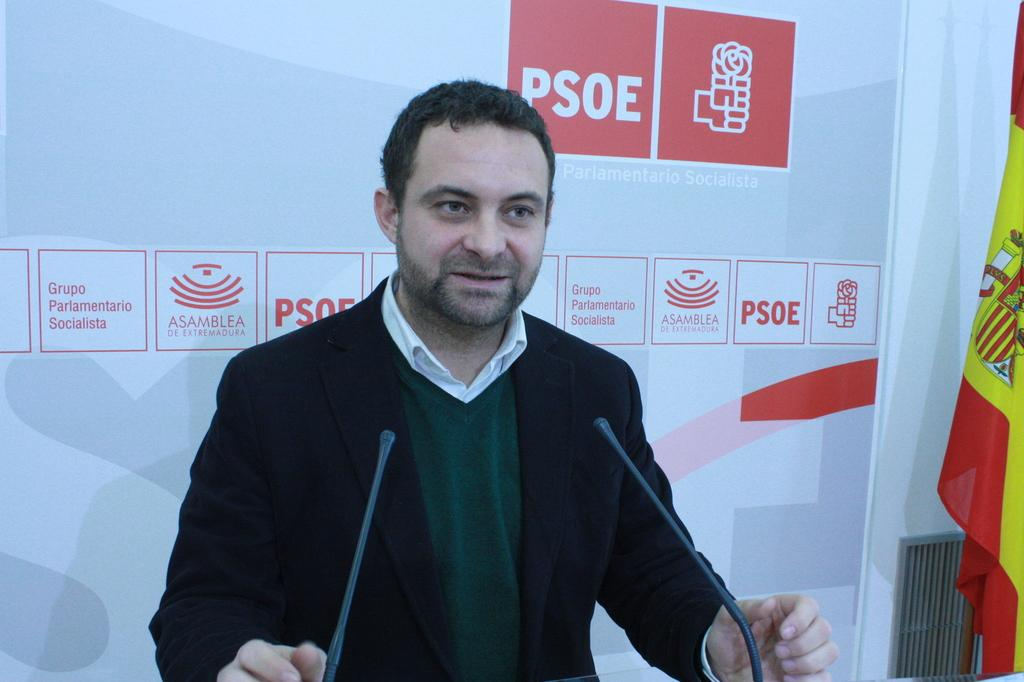What is the main subject of the image? There is a man standing in the center of the image. What is the man wearing? The man is wearing a suit. What objects are in front of the man? There are microphones (mics) in front of the man. What can be seen in the background of the image? There is a board in the background of the image. What is located on the right side of the image? There is a flag on the right side of the image. Can you tell me how many crows are perched on the man's shoulder in the image? There are no crows in the image; the man is standing alone with microphones in front of him. What type of grip does the jellyfish have on the flag in the image? There is no jellyfish present in the image; it features a man, microphones, a board, and a flag. 